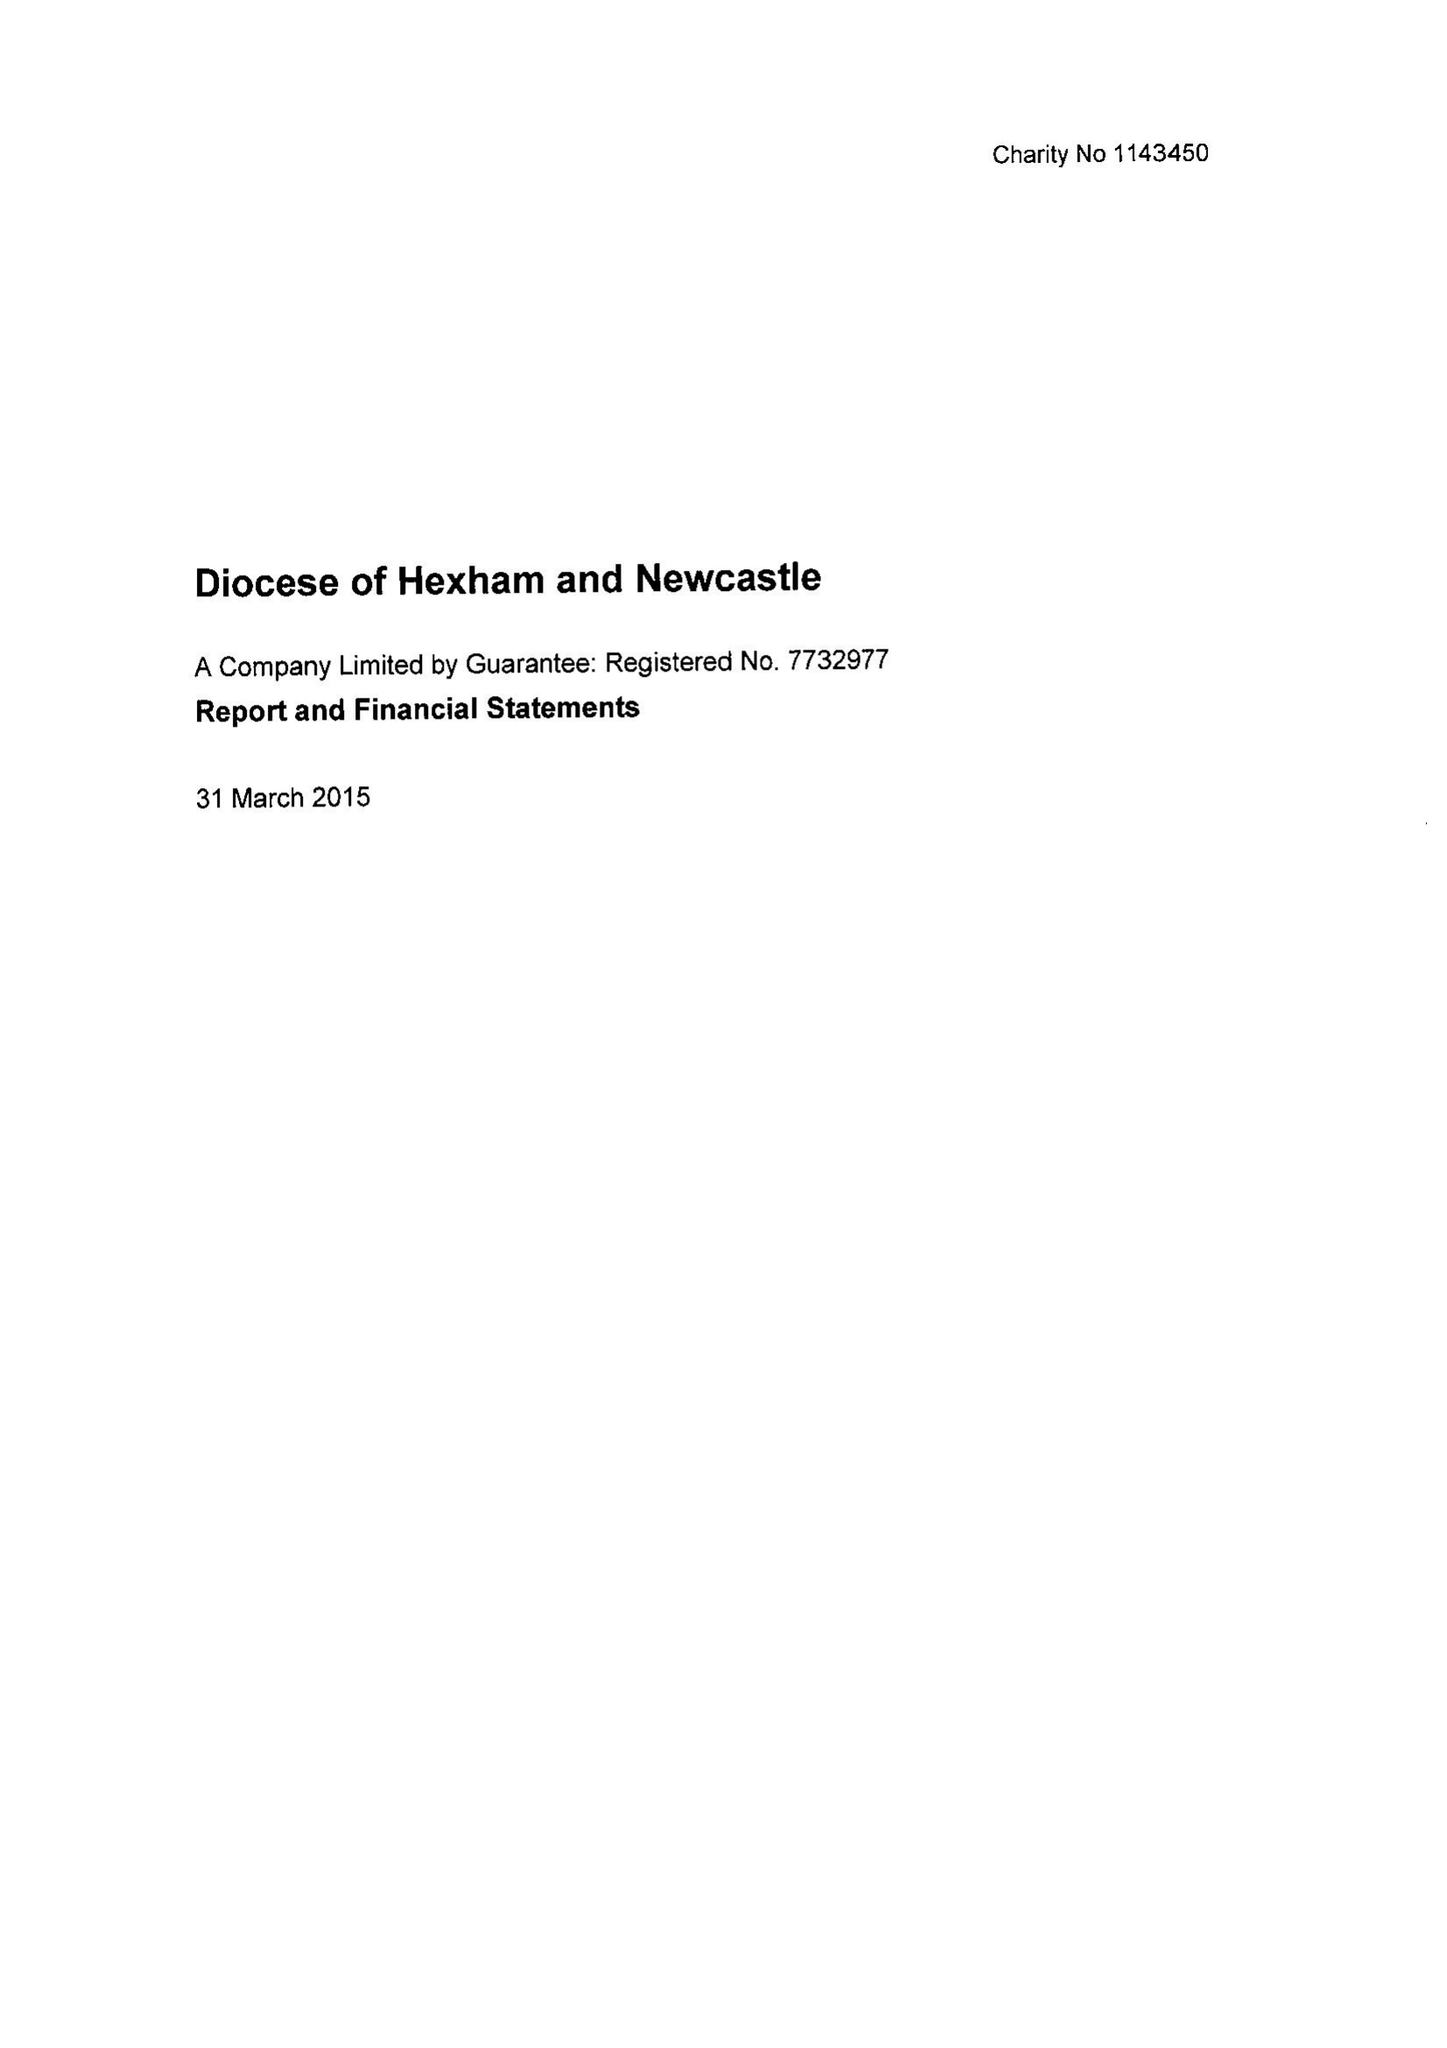What is the value for the address__postcode?
Answer the question using a single word or phrase. NE15 7PY 